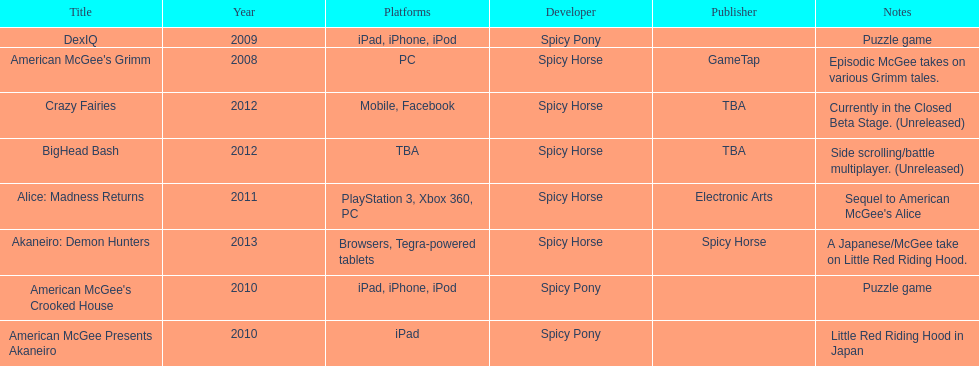How many games did spicy horse develop in total? 5. 